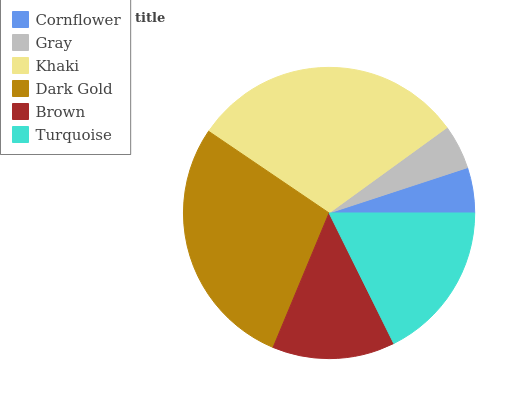Is Gray the minimum?
Answer yes or no. Yes. Is Khaki the maximum?
Answer yes or no. Yes. Is Khaki the minimum?
Answer yes or no. No. Is Gray the maximum?
Answer yes or no. No. Is Khaki greater than Gray?
Answer yes or no. Yes. Is Gray less than Khaki?
Answer yes or no. Yes. Is Gray greater than Khaki?
Answer yes or no. No. Is Khaki less than Gray?
Answer yes or no. No. Is Turquoise the high median?
Answer yes or no. Yes. Is Brown the low median?
Answer yes or no. Yes. Is Dark Gold the high median?
Answer yes or no. No. Is Khaki the low median?
Answer yes or no. No. 